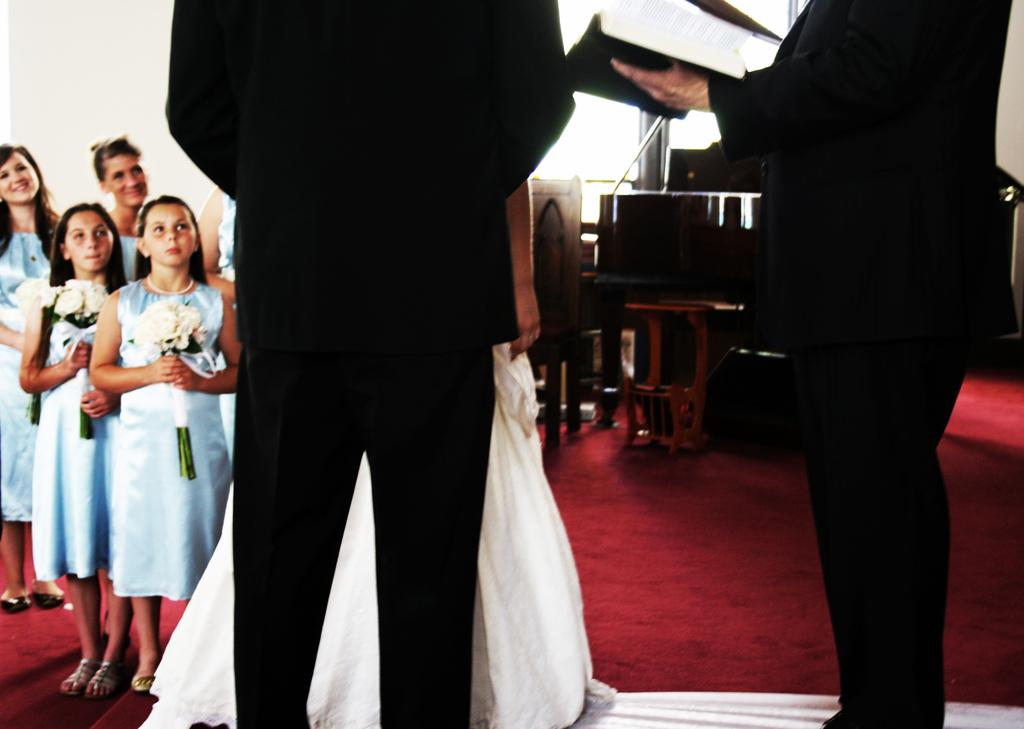How many people are standing in the image? There are two people standing in the image. What is the second person holding in their hand? The second person is holding a book in their hand. Can you describe the children in the image? Some of the children are present in the image, and some of them are holding flower bouquets. What type of sail can be seen in the image? There is no sail present in the image. What kind of plant is being used by the person in the image? There is no plant being used by the person in the image; the second person is holding a book. 